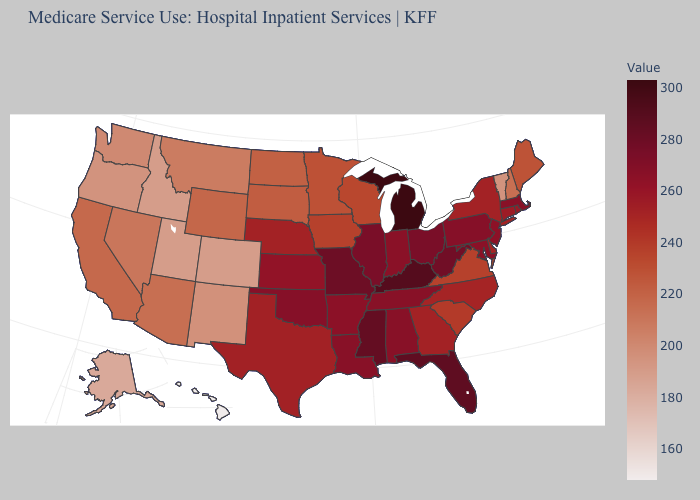Does the map have missing data?
Be succinct. No. Among the states that border Minnesota , which have the lowest value?
Answer briefly. North Dakota. Among the states that border Idaho , does Wyoming have the highest value?
Be succinct. Yes. Which states have the lowest value in the MidWest?
Answer briefly. North Dakota. 